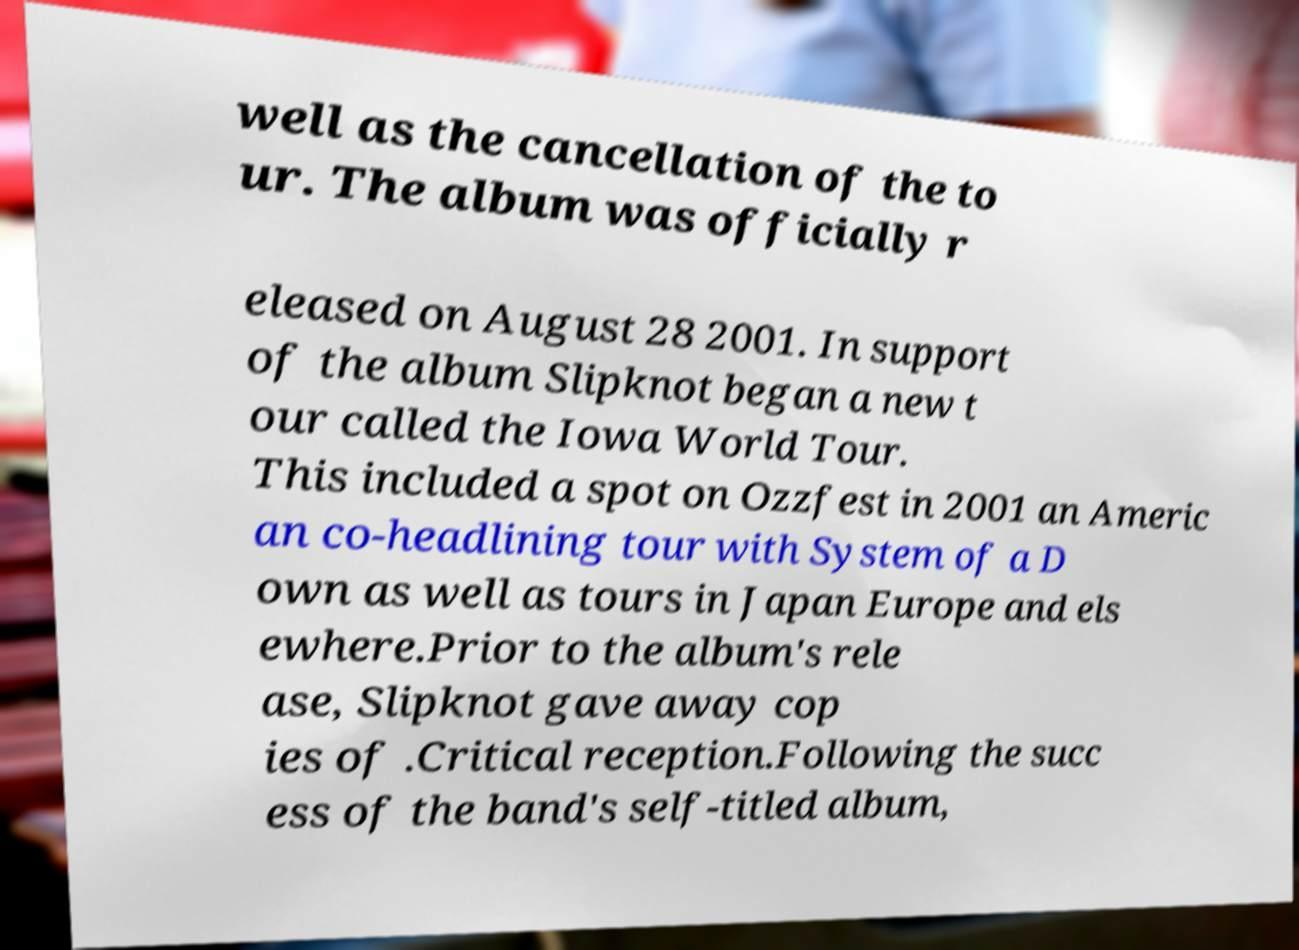What messages or text are displayed in this image? I need them in a readable, typed format. well as the cancellation of the to ur. The album was officially r eleased on August 28 2001. In support of the album Slipknot began a new t our called the Iowa World Tour. This included a spot on Ozzfest in 2001 an Americ an co-headlining tour with System of a D own as well as tours in Japan Europe and els ewhere.Prior to the album's rele ase, Slipknot gave away cop ies of .Critical reception.Following the succ ess of the band's self-titled album, 